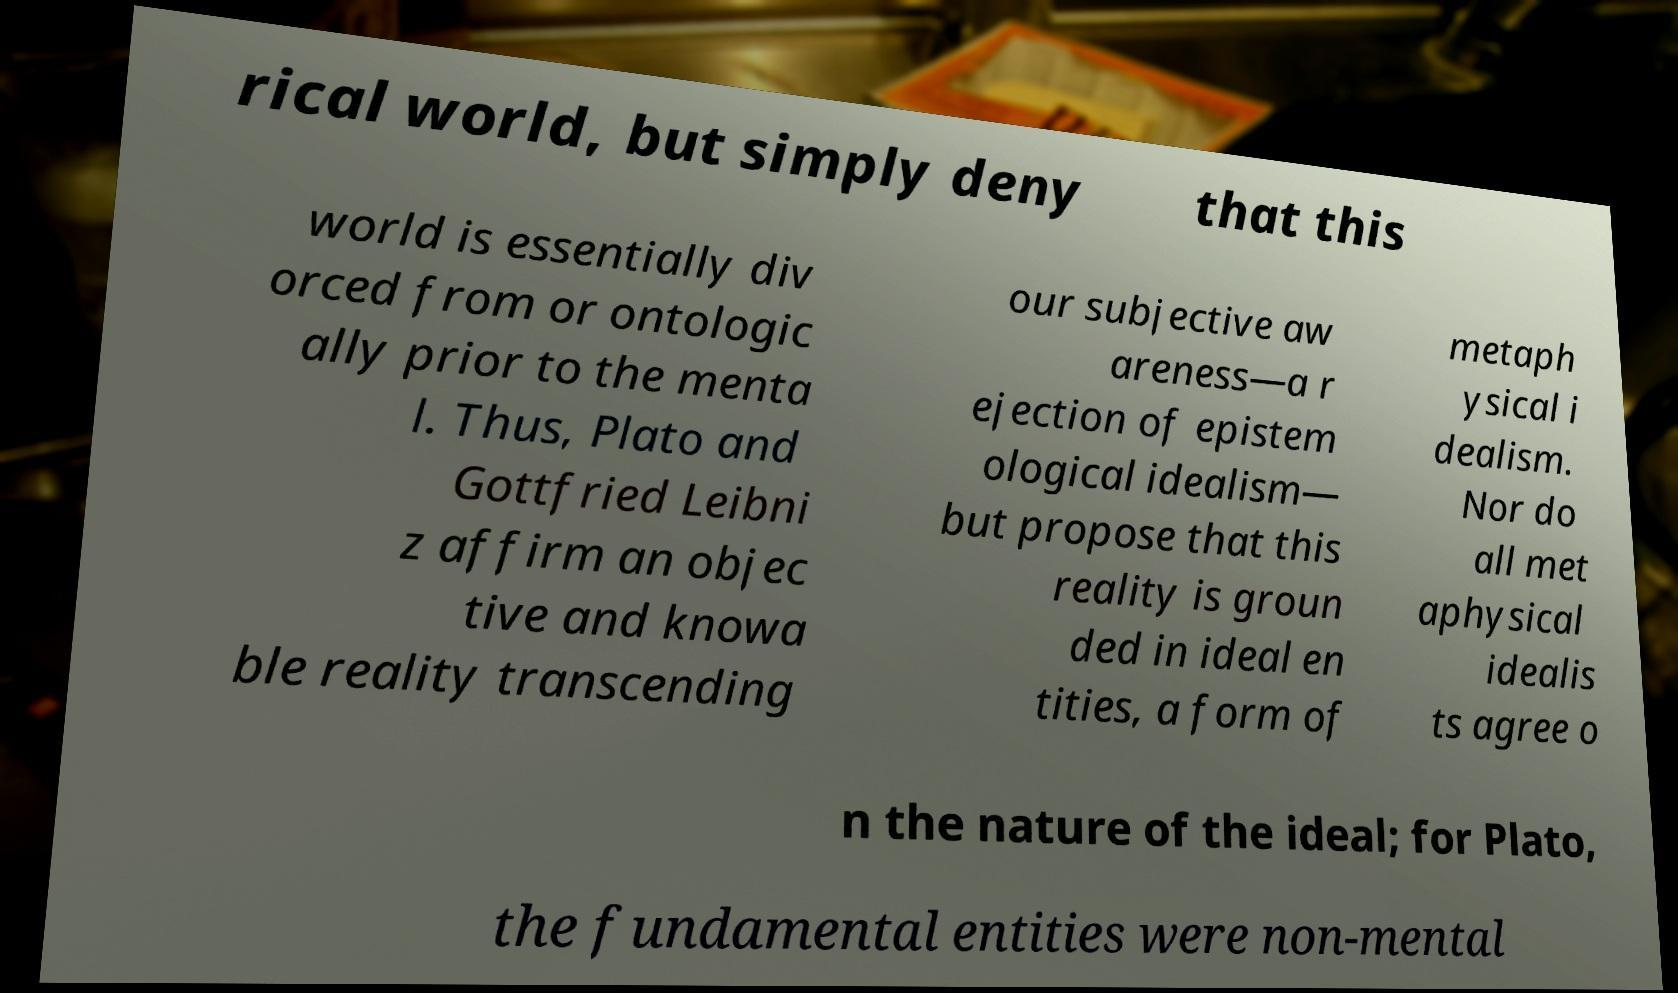Please read and relay the text visible in this image. What does it say? rical world, but simply deny that this world is essentially div orced from or ontologic ally prior to the menta l. Thus, Plato and Gottfried Leibni z affirm an objec tive and knowa ble reality transcending our subjective aw areness—a r ejection of epistem ological idealism— but propose that this reality is groun ded in ideal en tities, a form of metaph ysical i dealism. Nor do all met aphysical idealis ts agree o n the nature of the ideal; for Plato, the fundamental entities were non-mental 